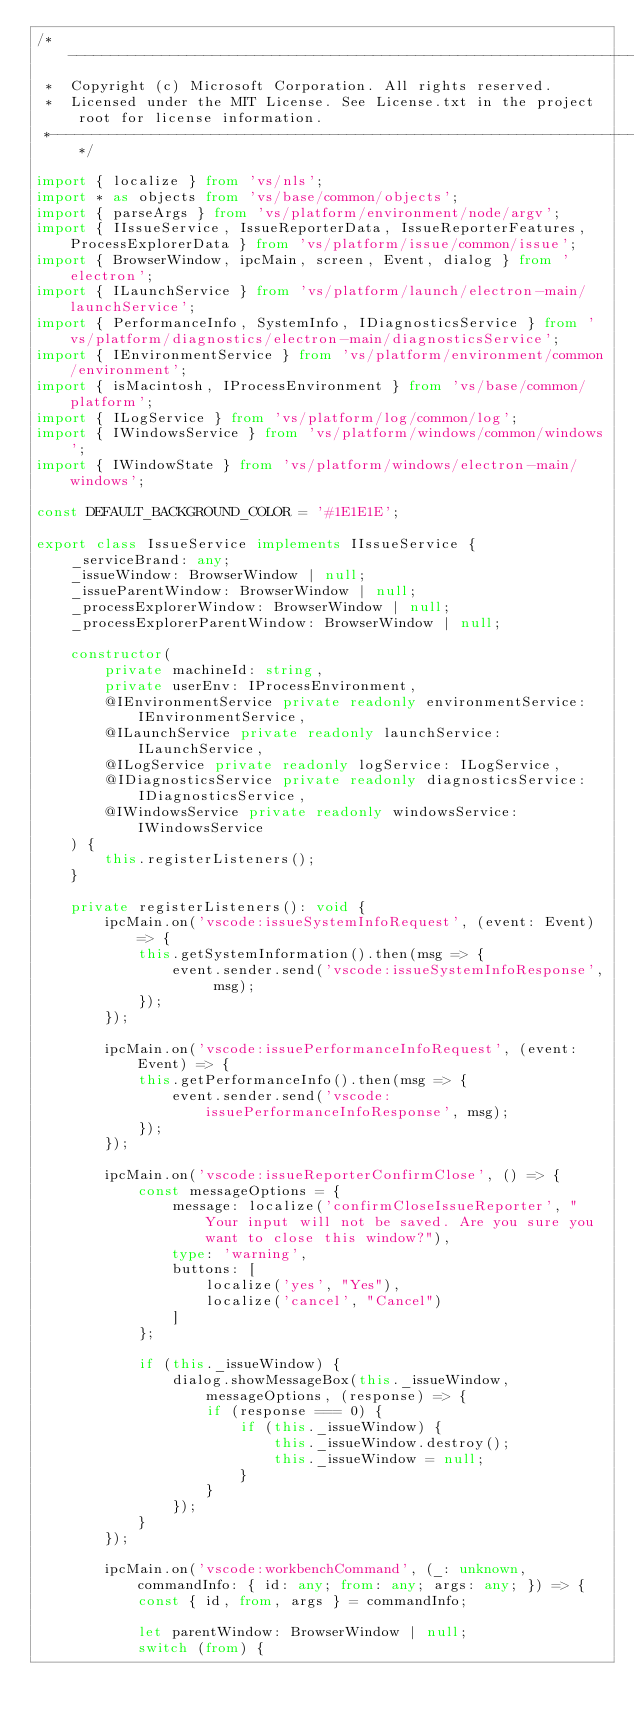Convert code to text. <code><loc_0><loc_0><loc_500><loc_500><_TypeScript_>/*---------------------------------------------------------------------------------------------
 *  Copyright (c) Microsoft Corporation. All rights reserved.
 *  Licensed under the MIT License. See License.txt in the project root for license information.
 *--------------------------------------------------------------------------------------------*/

import { localize } from 'vs/nls';
import * as objects from 'vs/base/common/objects';
import { parseArgs } from 'vs/platform/environment/node/argv';
import { IIssueService, IssueReporterData, IssueReporterFeatures, ProcessExplorerData } from 'vs/platform/issue/common/issue';
import { BrowserWindow, ipcMain, screen, Event, dialog } from 'electron';
import { ILaunchService } from 'vs/platform/launch/electron-main/launchService';
import { PerformanceInfo, SystemInfo, IDiagnosticsService } from 'vs/platform/diagnostics/electron-main/diagnosticsService';
import { IEnvironmentService } from 'vs/platform/environment/common/environment';
import { isMacintosh, IProcessEnvironment } from 'vs/base/common/platform';
import { ILogService } from 'vs/platform/log/common/log';
import { IWindowsService } from 'vs/platform/windows/common/windows';
import { IWindowState } from 'vs/platform/windows/electron-main/windows';

const DEFAULT_BACKGROUND_COLOR = '#1E1E1E';

export class IssueService implements IIssueService {
	_serviceBrand: any;
	_issueWindow: BrowserWindow | null;
	_issueParentWindow: BrowserWindow | null;
	_processExplorerWindow: BrowserWindow | null;
	_processExplorerParentWindow: BrowserWindow | null;

	constructor(
		private machineId: string,
		private userEnv: IProcessEnvironment,
		@IEnvironmentService private readonly environmentService: IEnvironmentService,
		@ILaunchService private readonly launchService: ILaunchService,
		@ILogService private readonly logService: ILogService,
		@IDiagnosticsService private readonly diagnosticsService: IDiagnosticsService,
		@IWindowsService private readonly windowsService: IWindowsService
	) {
		this.registerListeners();
	}

	private registerListeners(): void {
		ipcMain.on('vscode:issueSystemInfoRequest', (event: Event) => {
			this.getSystemInformation().then(msg => {
				event.sender.send('vscode:issueSystemInfoResponse', msg);
			});
		});

		ipcMain.on('vscode:issuePerformanceInfoRequest', (event: Event) => {
			this.getPerformanceInfo().then(msg => {
				event.sender.send('vscode:issuePerformanceInfoResponse', msg);
			});
		});

		ipcMain.on('vscode:issueReporterConfirmClose', () => {
			const messageOptions = {
				message: localize('confirmCloseIssueReporter', "Your input will not be saved. Are you sure you want to close this window?"),
				type: 'warning',
				buttons: [
					localize('yes', "Yes"),
					localize('cancel', "Cancel")
				]
			};

			if (this._issueWindow) {
				dialog.showMessageBox(this._issueWindow, messageOptions, (response) => {
					if (response === 0) {
						if (this._issueWindow) {
							this._issueWindow.destroy();
							this._issueWindow = null;
						}
					}
				});
			}
		});

		ipcMain.on('vscode:workbenchCommand', (_: unknown, commandInfo: { id: any; from: any; args: any; }) => {
			const { id, from, args } = commandInfo;

			let parentWindow: BrowserWindow | null;
			switch (from) {</code> 